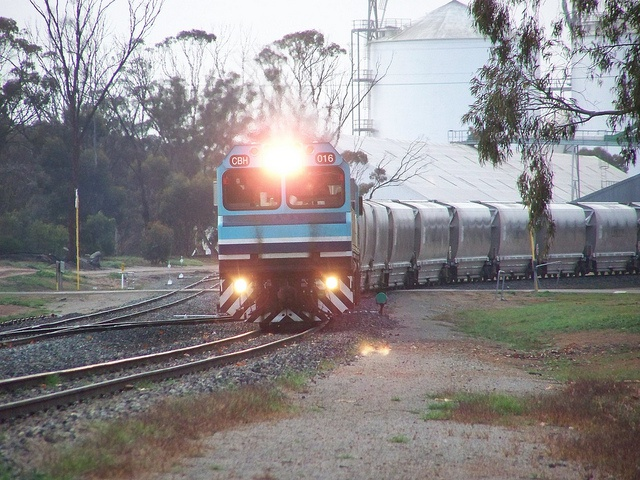Describe the objects in this image and their specific colors. I can see a train in lightgray, gray, brown, white, and darkgray tones in this image. 